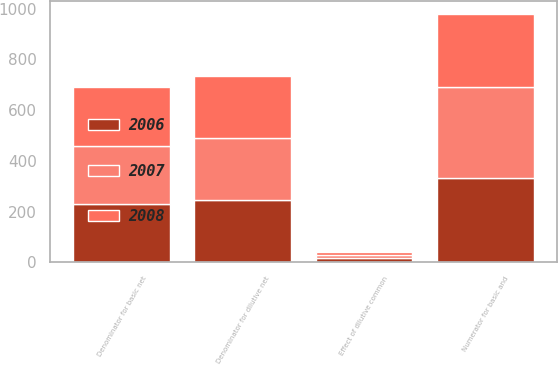<chart> <loc_0><loc_0><loc_500><loc_500><stacked_bar_chart><ecel><fcel>Numerator for basic and<fcel>Denominator for basic net<fcel>Effect of dilutive common<fcel>Denominator for dilutive net<nl><fcel>2007<fcel>356.2<fcel>230.3<fcel>11.7<fcel>242<nl><fcel>2008<fcel>289.7<fcel>230.7<fcel>12.5<fcel>243.2<nl><fcel>2006<fcel>333.6<fcel>229<fcel>18.5<fcel>247.5<nl></chart> 